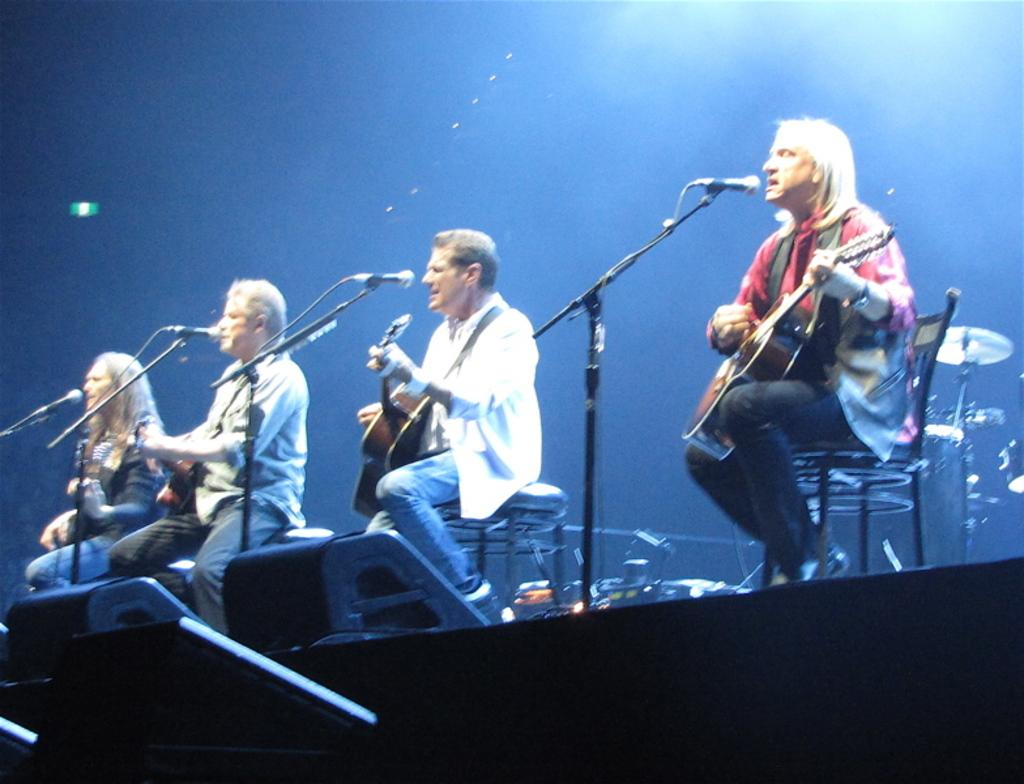How many people are in the image? There are four people in the image. What are the people doing in the image? The people are sitting on chairs and playing musical instruments. What object is in front of the people? There is a microphone in front of the people. What can be seen above the people? There is a light visible on top. How many passengers are sitting on the chairs in the image? There is no reference to passengers in the image; the people are playing musical instruments. What color are the eyes of the person playing the guitar in the image? There is no information about the color of anyone's eyes in the image. 